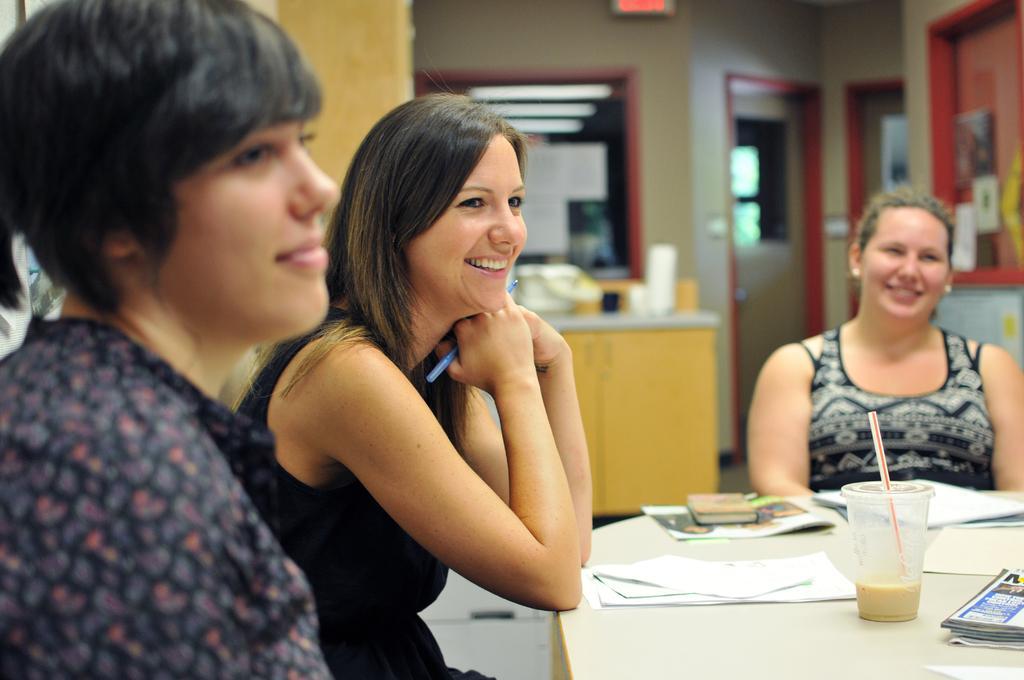Can you describe this image briefly? In the image we can see there are women who are sitting on chair and on table there is a coffee glass and papers. 